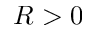Convert formula to latex. <formula><loc_0><loc_0><loc_500><loc_500>R > 0</formula> 